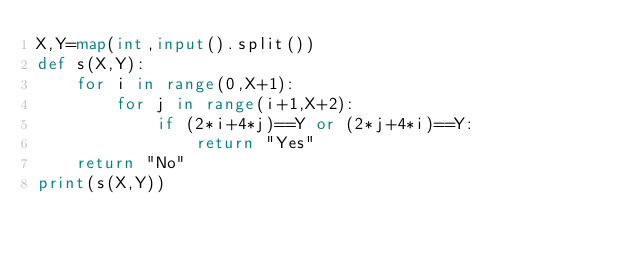<code> <loc_0><loc_0><loc_500><loc_500><_Python_>X,Y=map(int,input().split())
def s(X,Y):
    for i in range(0,X+1):
        for j in range(i+1,X+2):
            if (2*i+4*j)==Y or (2*j+4*i)==Y:
                return "Yes"
    return "No"
print(s(X,Y))</code> 